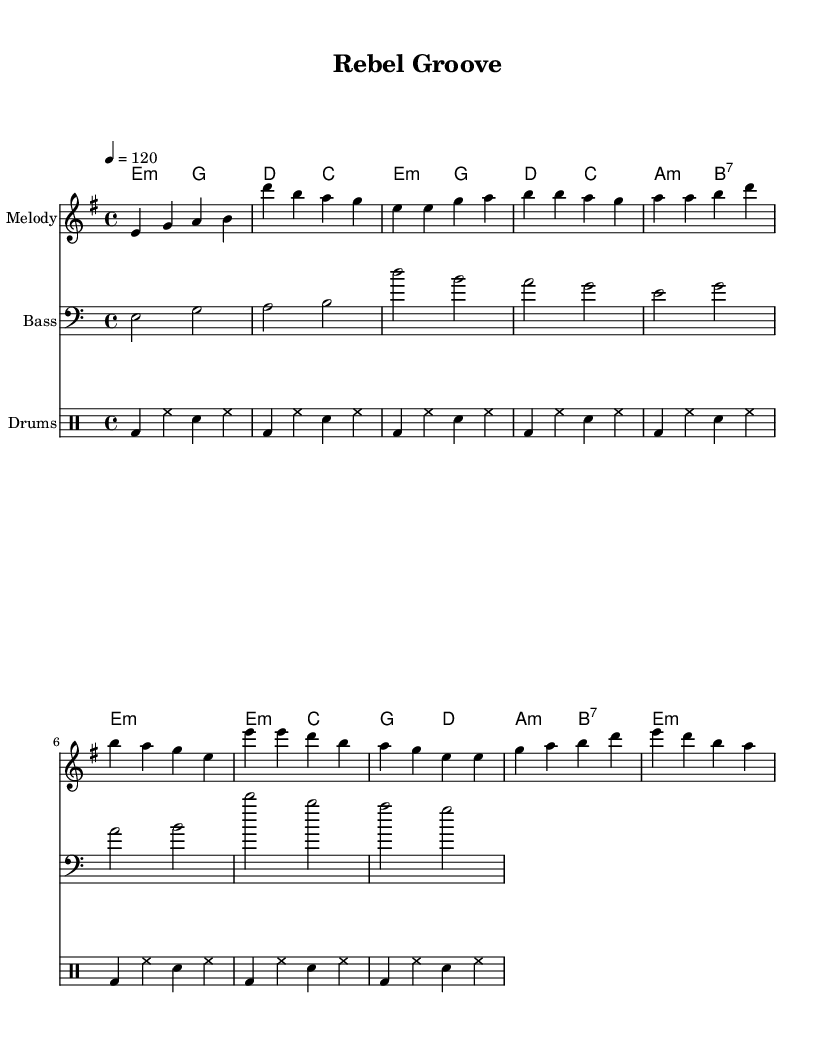What is the key signature of this piece? The key signature shows two sharps, which indicates that the key is E minor. The key signature is determined by looking at the accidentals at the beginning of the staff.
Answer: E minor What is the time signature of the music? The time signature is indicated by the fraction at the beginning of the piece. Here, it shows 4/4, meaning there are four beats in a measure, and the quarter note gets one beat.
Answer: 4/4 What is the tempo marking given for this piece? The tempo marking is found in the text at the beginning, indicating beats per minute. It states "4 = 120", meaning that there should be 120 beats per minute, specifically using quarter note beats.
Answer: 120 How many measures are in the intro section? By observing the number of distinct phrases within the intro section, which consists of two measures - e4 g a b and d' b a g.
Answer: 2 Which chord is played during the chorus section? Upon examining the chord symbols above the melody notes during the chorus, the primary chords listed are e minor and b7, highlighting a common structure in Disco music aimed at creating a danceable rhythm.
Answer: e minor, b7 What is the highest note in the melody? The highest note in the melody can be identified by scanning through the pitches written in the melody staff. The note d' (D in the octave above middle C) is the highest mentioned.
Answer: d' What is the rhythm pattern for the drums? The rhythm for the drums is found in the drummode section, where it indicates a repeated pattern over the measures. The pattern combines bass drum, hi-hats, and snare in a consistent sequence.
Answer: bass drum, hi-hats, snare 